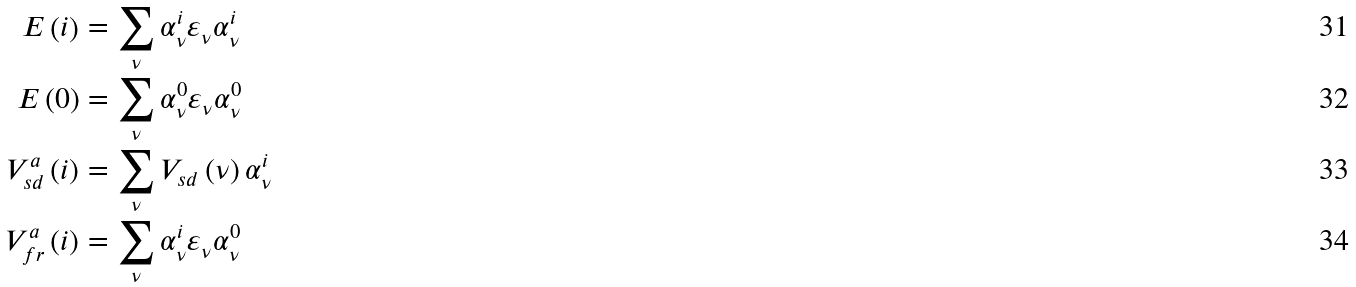<formula> <loc_0><loc_0><loc_500><loc_500>E \left ( i \right ) & = \sum _ { \nu } \alpha _ { \nu } ^ { i } \varepsilon _ { \nu } \alpha _ { \nu } ^ { i } \\ E \left ( 0 \right ) & = \sum _ { \nu } \alpha _ { \nu } ^ { 0 } \varepsilon _ { \nu } \alpha _ { \nu } ^ { 0 } \\ V _ { s d } ^ { a } \left ( i \right ) & = \sum _ { \nu } V _ { s d } \left ( \nu \right ) \alpha _ { \nu } ^ { i } \\ V _ { f r } ^ { a } \left ( i \right ) & = \sum _ { \nu } \alpha _ { \nu } ^ { i } \varepsilon _ { \nu } \alpha _ { \nu } ^ { 0 }</formula> 